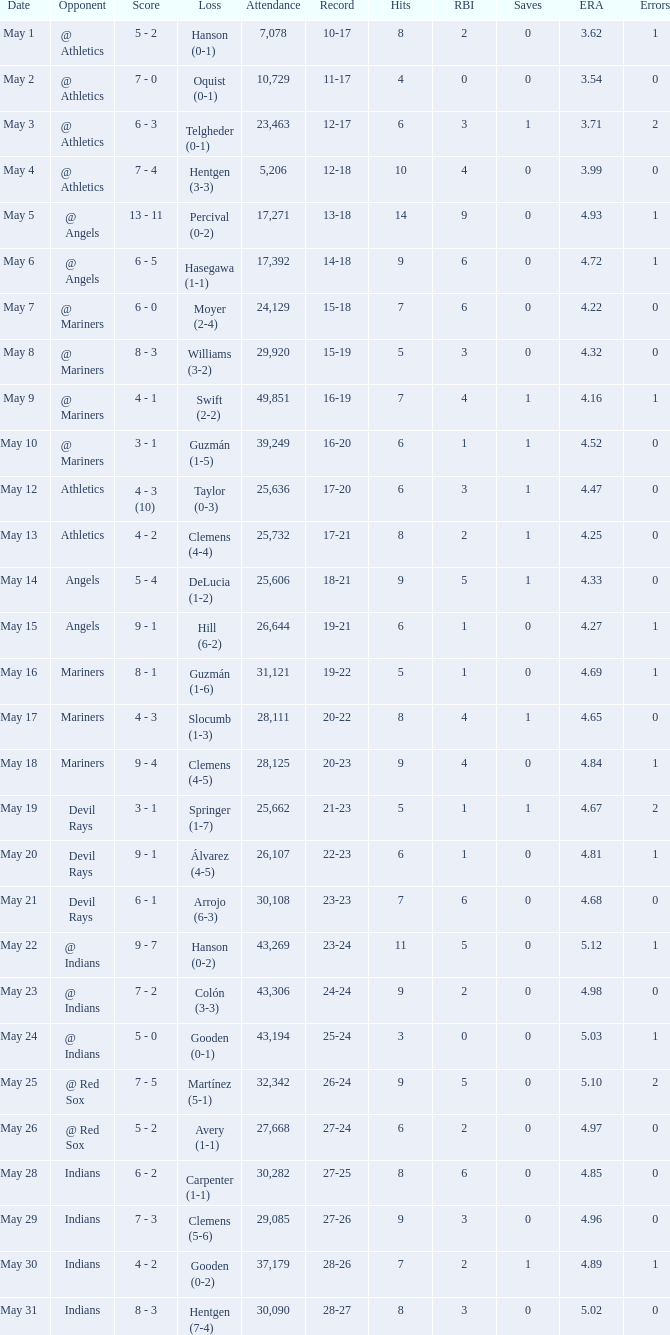Could you parse the entire table? {'header': ['Date', 'Opponent', 'Score', 'Loss', 'Attendance', 'Record', 'Hits', 'RBI', 'Saves', 'ERA', 'Errors'], 'rows': [['May 1', '@ Athletics', '5 - 2', 'Hanson (0-1)', '7,078', '10-17', '8', '2', '0', '3.62', '1'], ['May 2', '@ Athletics', '7 - 0', 'Oquist (0-1)', '10,729', '11-17', '4', '0', '0', '3.54', '0'], ['May 3', '@ Athletics', '6 - 3', 'Telgheder (0-1)', '23,463', '12-17', '6', '3', '1', '3.71', '2'], ['May 4', '@ Athletics', '7 - 4', 'Hentgen (3-3)', '5,206', '12-18', '10', '4', '0', '3.99', '0'], ['May 5', '@ Angels', '13 - 11', 'Percival (0-2)', '17,271', '13-18', '14', '9', '0', '4.93', '1'], ['May 6', '@ Angels', '6 - 5', 'Hasegawa (1-1)', '17,392', '14-18', '9', '6', '0', '4.72', '1'], ['May 7', '@ Mariners', '6 - 0', 'Moyer (2-4)', '24,129', '15-18', '7', '6', '0', '4.22', '0'], ['May 8', '@ Mariners', '8 - 3', 'Williams (3-2)', '29,920', '15-19', '5', '3', '0', '4.32', '0'], ['May 9', '@ Mariners', '4 - 1', 'Swift (2-2)', '49,851', '16-19', '7', '4', '1', '4.16', '1'], ['May 10', '@ Mariners', '3 - 1', 'Guzmán (1-5)', '39,249', '16-20', '6', '1', '1', '4.52', '0'], ['May 12', 'Athletics', '4 - 3 (10)', 'Taylor (0-3)', '25,636', '17-20', '6', '3', '1', '4.47', '0'], ['May 13', 'Athletics', '4 - 2', 'Clemens (4-4)', '25,732', '17-21', '8', '2', '1', '4.25', '0'], ['May 14', 'Angels', '5 - 4', 'DeLucia (1-2)', '25,606', '18-21', '9', '5', '1', '4.33', '0'], ['May 15', 'Angels', '9 - 1', 'Hill (6-2)', '26,644', '19-21', '6', '1', '0', '4.27', '1'], ['May 16', 'Mariners', '8 - 1', 'Guzmán (1-6)', '31,121', '19-22', '5', '1', '0', '4.69', '1'], ['May 17', 'Mariners', '4 - 3', 'Slocumb (1-3)', '28,111', '20-22', '8', '4', '1', '4.65', '0'], ['May 18', 'Mariners', '9 - 4', 'Clemens (4-5)', '28,125', '20-23', '9', '4', '0', '4.84', '1'], ['May 19', 'Devil Rays', '3 - 1', 'Springer (1-7)', '25,662', '21-23', '5', '1', '1', '4.67', '2'], ['May 20', 'Devil Rays', '9 - 1', 'Álvarez (4-5)', '26,107', '22-23', '6', '1', '0', '4.81', '1'], ['May 21', 'Devil Rays', '6 - 1', 'Arrojo (6-3)', '30,108', '23-23', '7', '6', '0', '4.68', '0'], ['May 22', '@ Indians', '9 - 7', 'Hanson (0-2)', '43,269', '23-24', '11', '5', '0', '5.12', '1'], ['May 23', '@ Indians', '7 - 2', 'Colón (3-3)', '43,306', '24-24', '9', '2', '0', '4.98', '0'], ['May 24', '@ Indians', '5 - 0', 'Gooden (0-1)', '43,194', '25-24', '3', '0', '0', '5.03', '1'], ['May 25', '@ Red Sox', '7 - 5', 'Martínez (5-1)', '32,342', '26-24', '9', '5', '0', '5.10', '2'], ['May 26', '@ Red Sox', '5 - 2', 'Avery (1-1)', '27,668', '27-24', '6', '2', '0', '4.97', '0'], ['May 28', 'Indians', '6 - 2', 'Carpenter (1-1)', '30,282', '27-25', '8', '6', '0', '4.85', '0'], ['May 29', 'Indians', '7 - 3', 'Clemens (5-6)', '29,085', '27-26', '9', '3', '0', '4.96', '0'], ['May 30', 'Indians', '4 - 2', 'Gooden (0-2)', '37,179', '28-26', '7', '2', '1', '4.89', '1'], ['May 31', 'Indians', '8 - 3', 'Hentgen (7-4)', '30,090', '28-27', '8', '3', '0', '5.02', '0']]} What is the record for May 31? 28-27. 